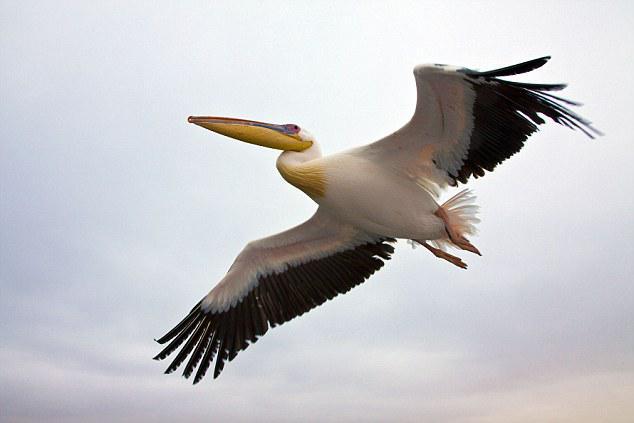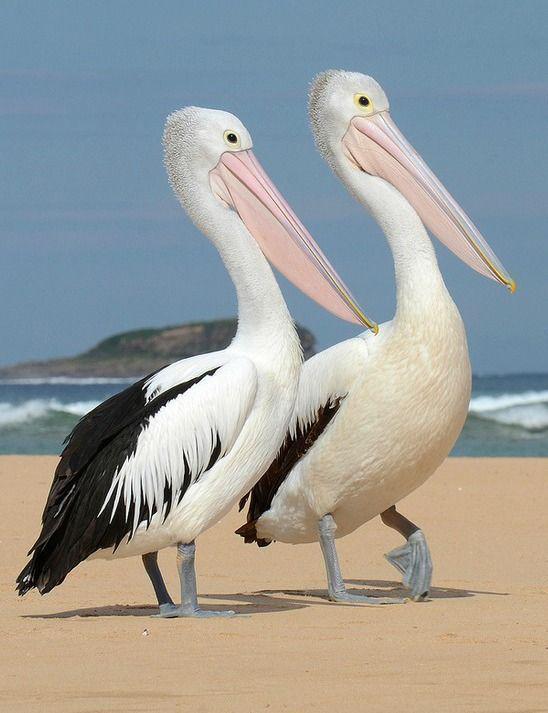The first image is the image on the left, the second image is the image on the right. Considering the images on both sides, is "An image shows a single gliding pelican with wings extended." valid? Answer yes or no. Yes. 